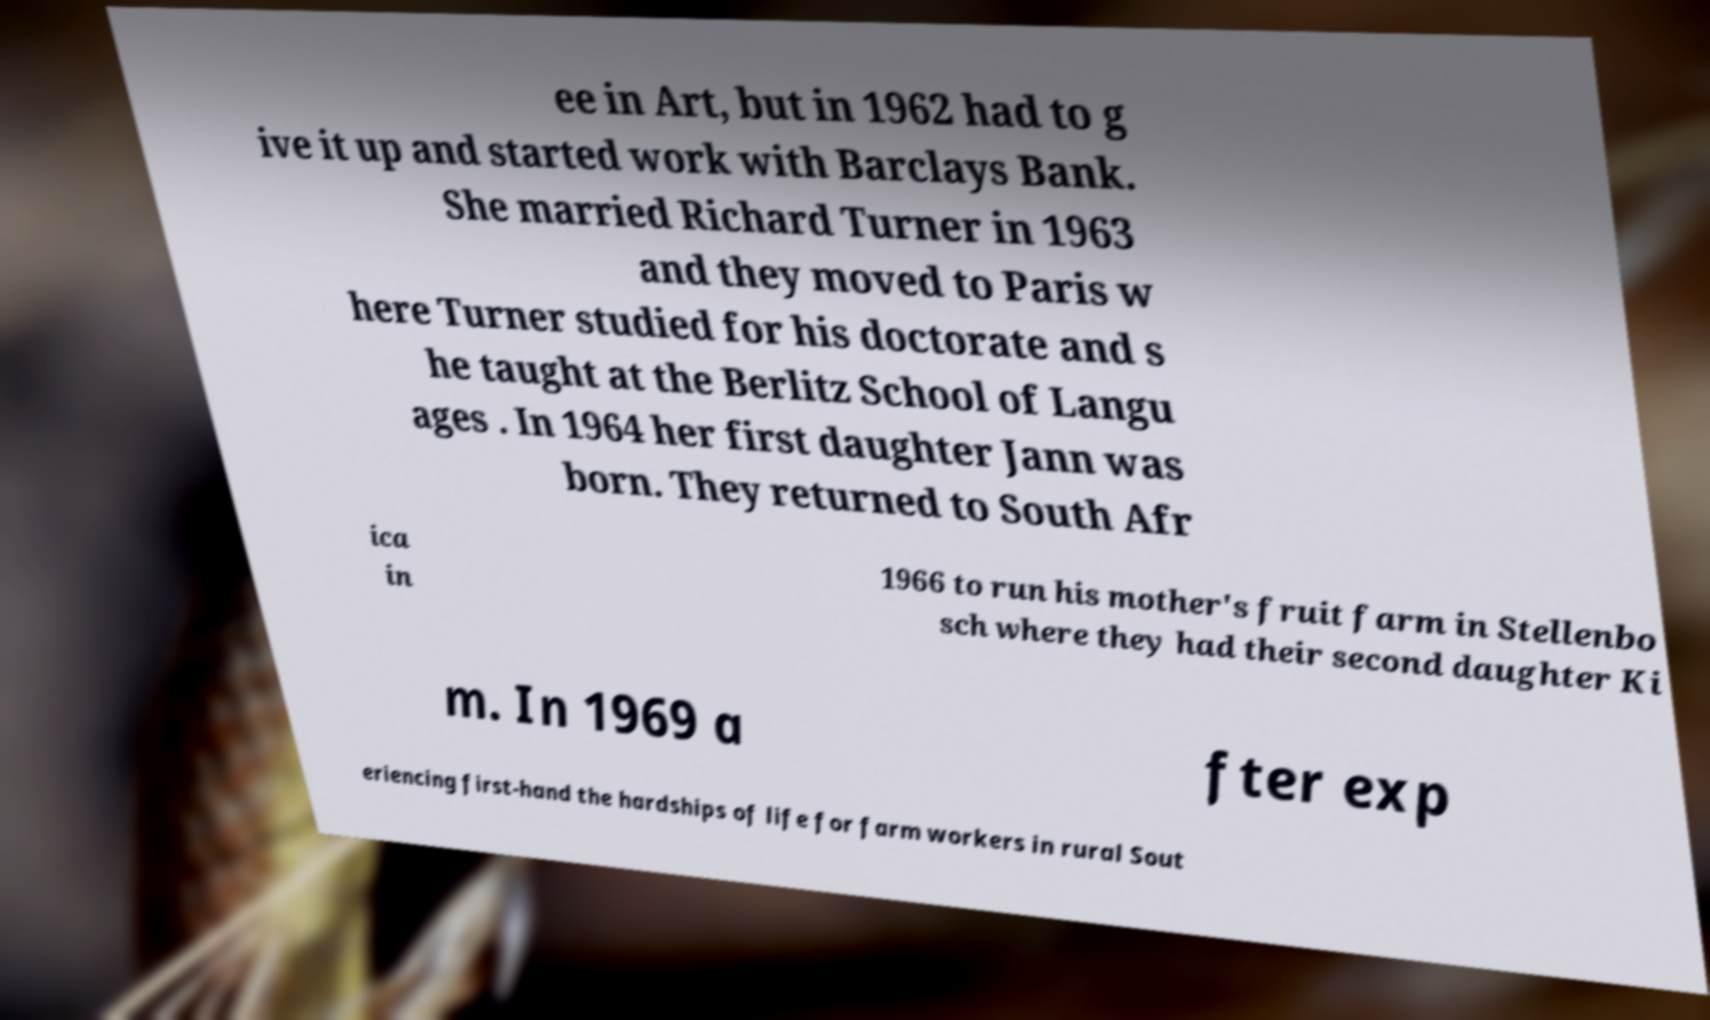Can you read and provide the text displayed in the image?This photo seems to have some interesting text. Can you extract and type it out for me? ee in Art, but in 1962 had to g ive it up and started work with Barclays Bank. She married Richard Turner in 1963 and they moved to Paris w here Turner studied for his doctorate and s he taught at the Berlitz School of Langu ages . In 1964 her first daughter Jann was born. They returned to South Afr ica in 1966 to run his mother's fruit farm in Stellenbo sch where they had their second daughter Ki m. In 1969 a fter exp eriencing first-hand the hardships of life for farm workers in rural Sout 